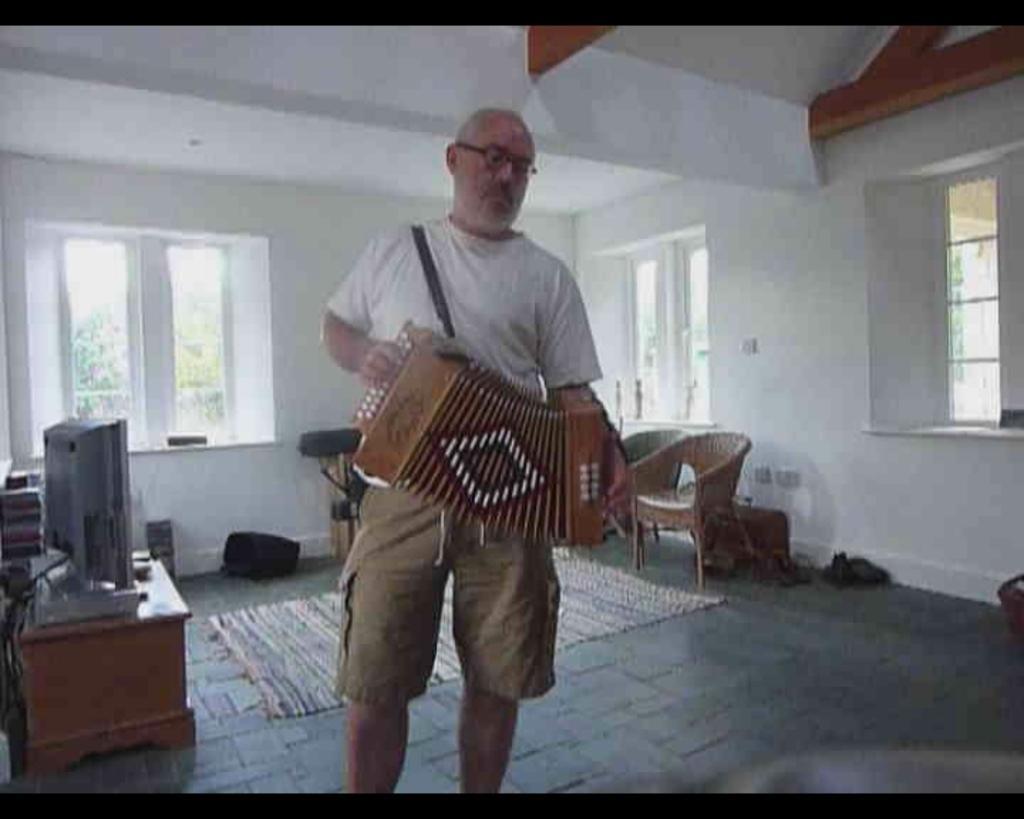Please provide a concise description of this image. In the picture we can see a man standing and holding a musical instrument and playing it and he is wearing a white T-shirt and behind we can see some floor mat and a table on it, we can see a TV and opposite to it we can see some chairs near the wall and some windows to it. 